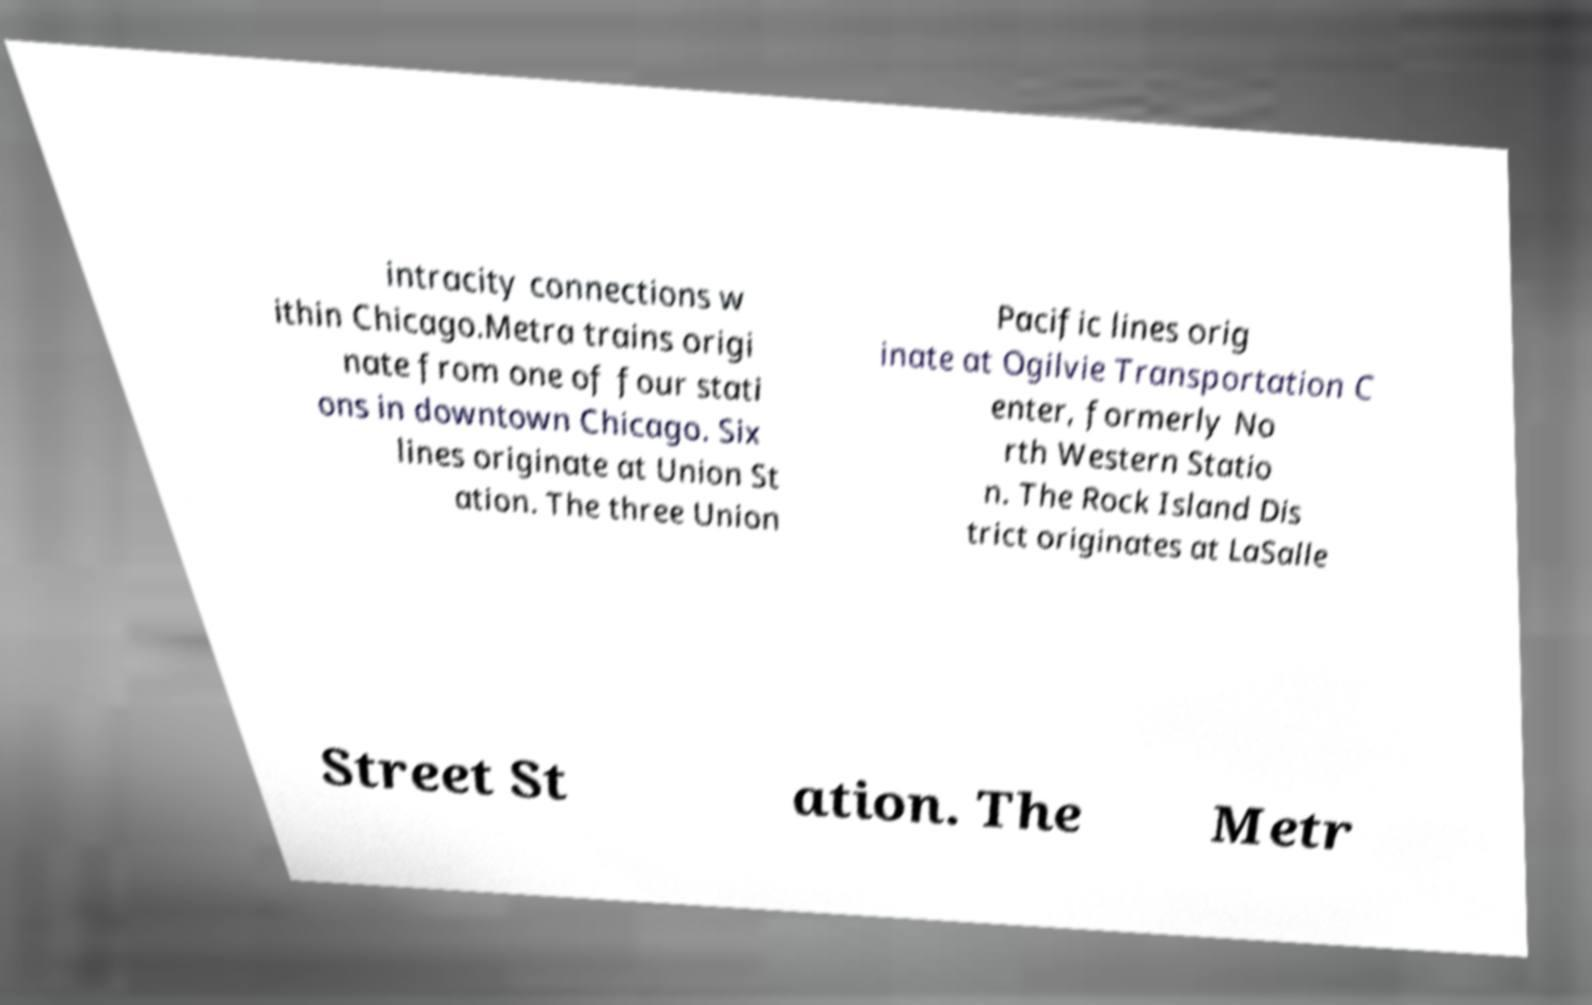Please identify and transcribe the text found in this image. intracity connections w ithin Chicago.Metra trains origi nate from one of four stati ons in downtown Chicago. Six lines originate at Union St ation. The three Union Pacific lines orig inate at Ogilvie Transportation C enter, formerly No rth Western Statio n. The Rock Island Dis trict originates at LaSalle Street St ation. The Metr 